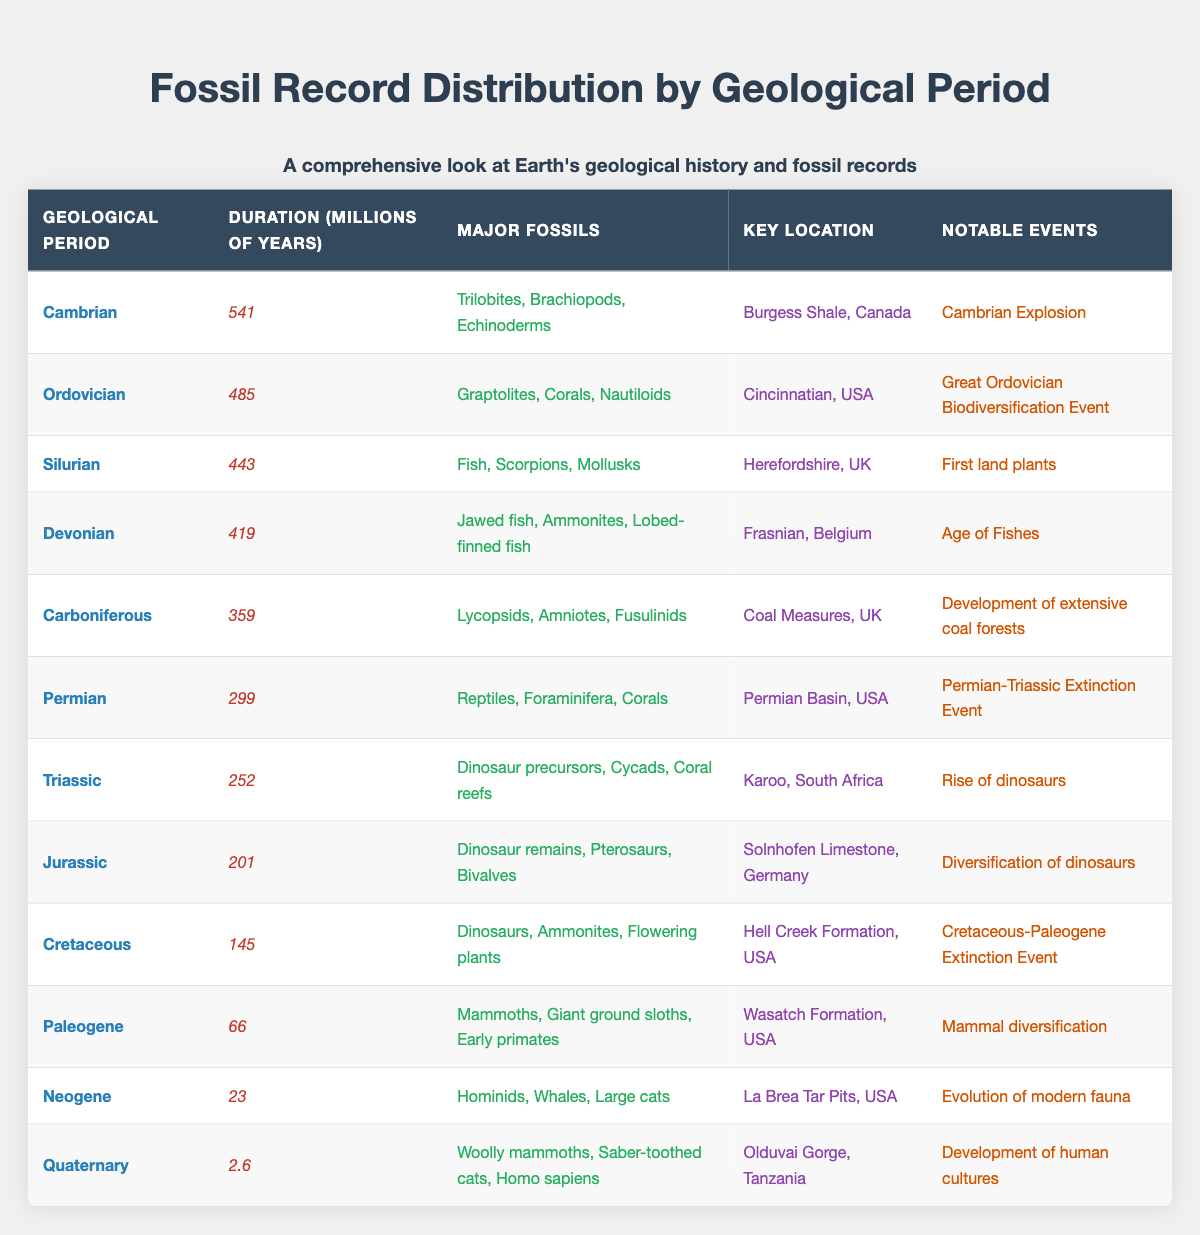What is the key location for the Devonian period? The key location for the Devonian period is listed as the Frasnian, Belgium in the table.
Answer: Frasnian, Belgium Which geological period has the longest duration? By examining the "Duration (Millions of Years)" column, the Cambrian period, with a duration of 541 million years, has the longest duration compared to all other periods listed.
Answer: Cambrian How many major fossils are listed for the Neogene period? The table indicates that the major fossils for the Neogene period are Hominids, Whales, and Large cats, totaling three major fossils.
Answer: 3 Is the Permian period associated with the 'Permian-Triassic Extinction Event'? According to the table, the Permian period's notable events include the 'Permian-Triassic Extinction Event', confirming that this statement is true.
Answer: Yes What is the average duration of the geological periods from the Cambrian to the Quaternary? The durations for the periods are: Cambrian 541, Ordovician 485, Silurian 443, Devonian 419, Carboniferous 359, Permian 299, Triassic 252, Jurassic 201, Cretaceous 145, Paleogene 66, Neogene 23, Quaternary 2.6. Summing these gives 2029.6 million years. Dividing by 11 periods gives an average duration of approximately 184.51 million years.
Answer: 184.51 During which period did the first land plants appear? The first land plants appeared during the Silurian period, as noted in the notable events section of that period in the table.
Answer: Silurian 